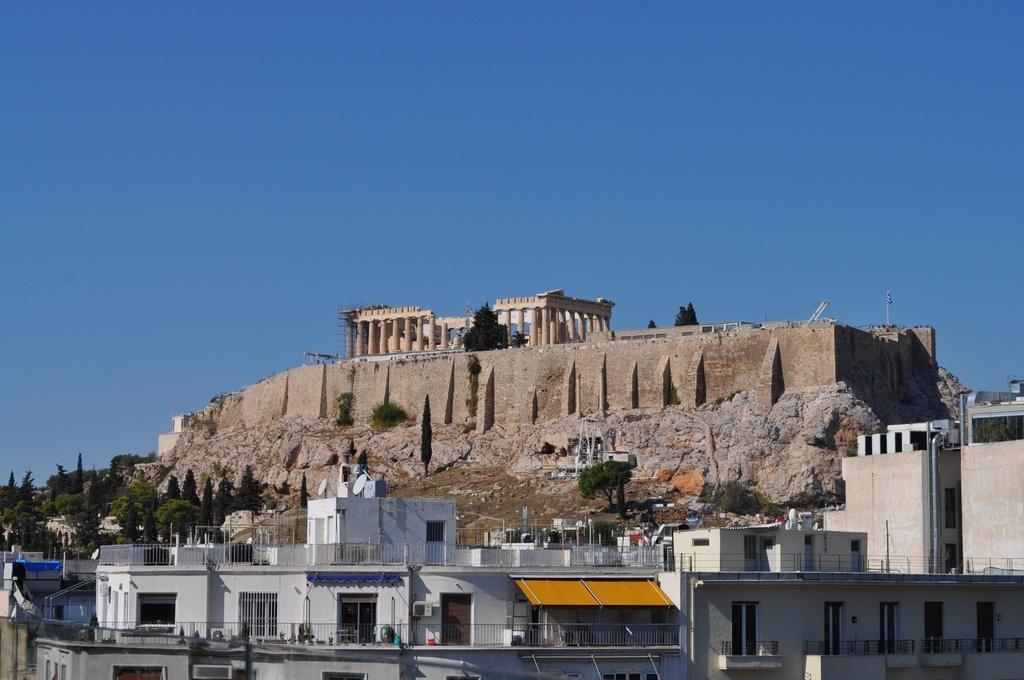Describe this image in one or two sentences. In this image we can see buildings with windows and doors. Also there are railings. In the back we can see trees. Also there is a fort. And there are pillars. And there is sky. 